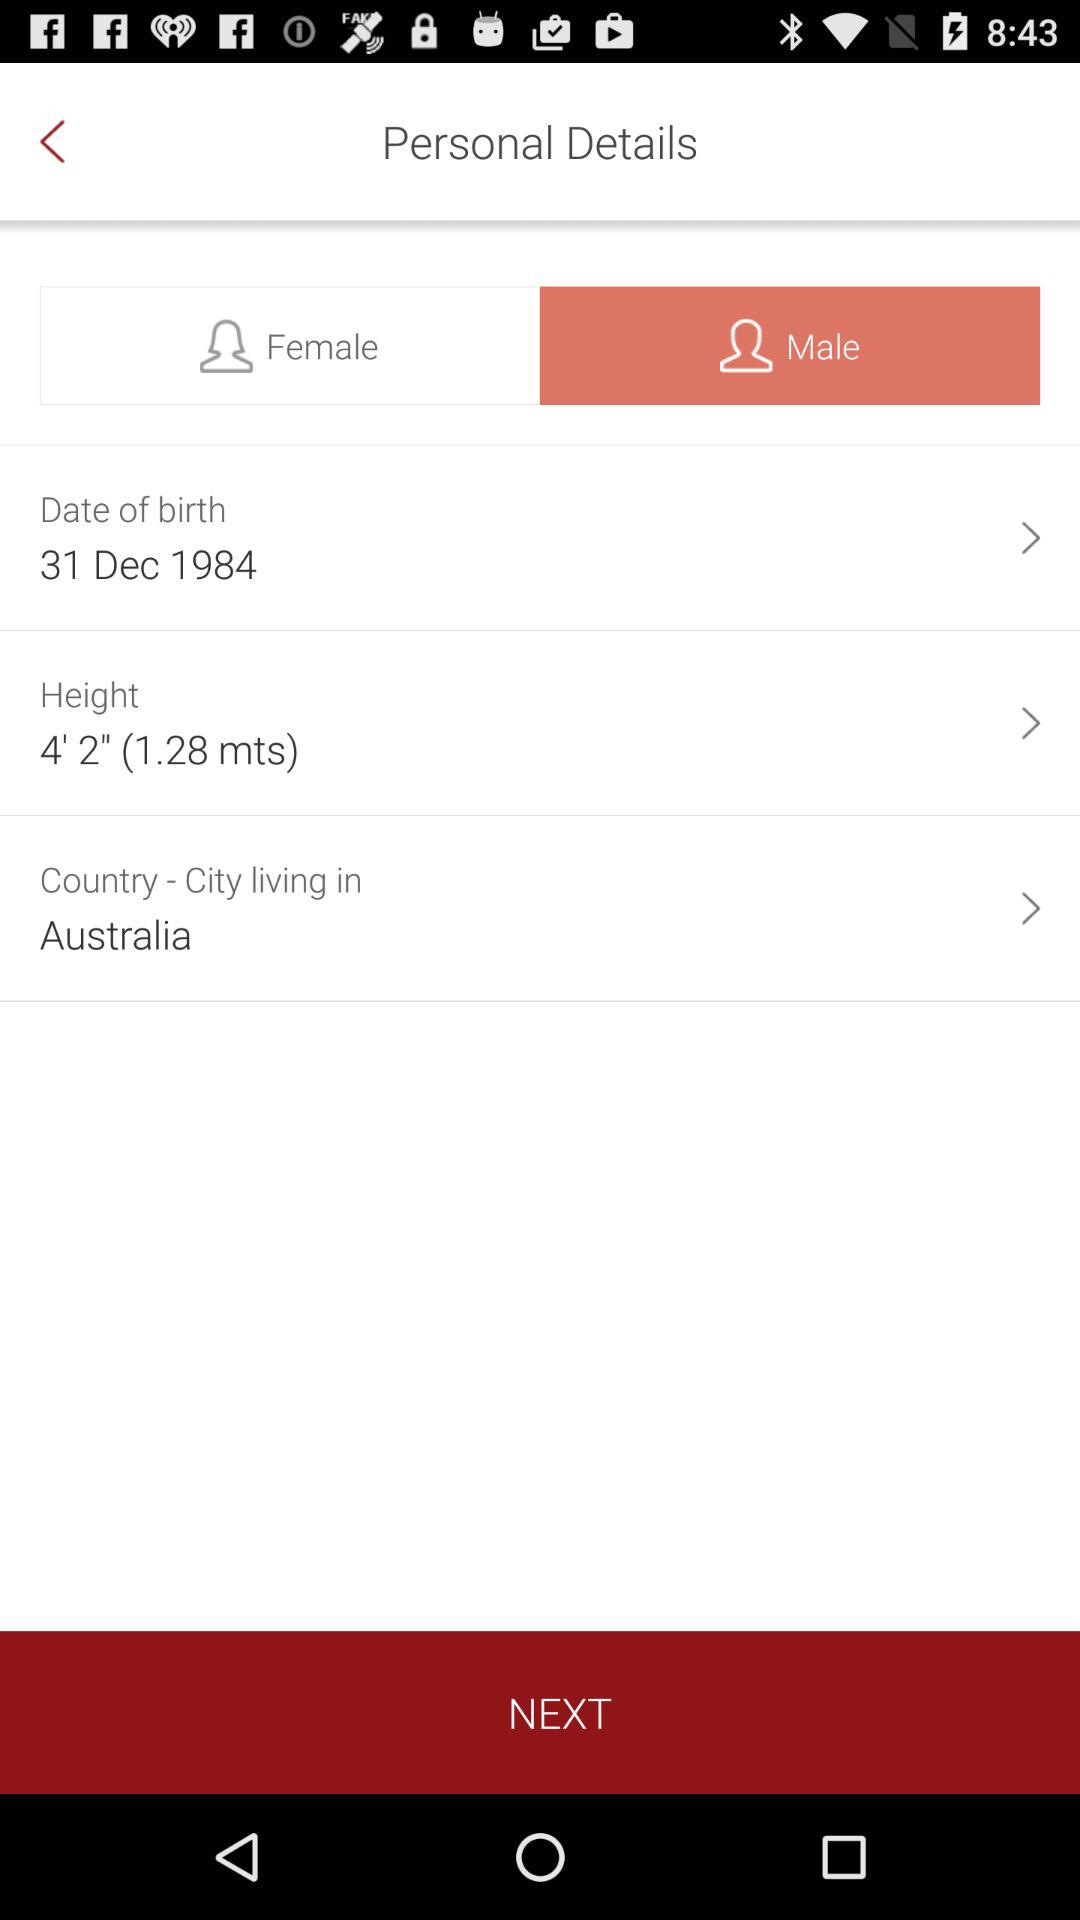What gender is selected? The selected gender is "Male". 